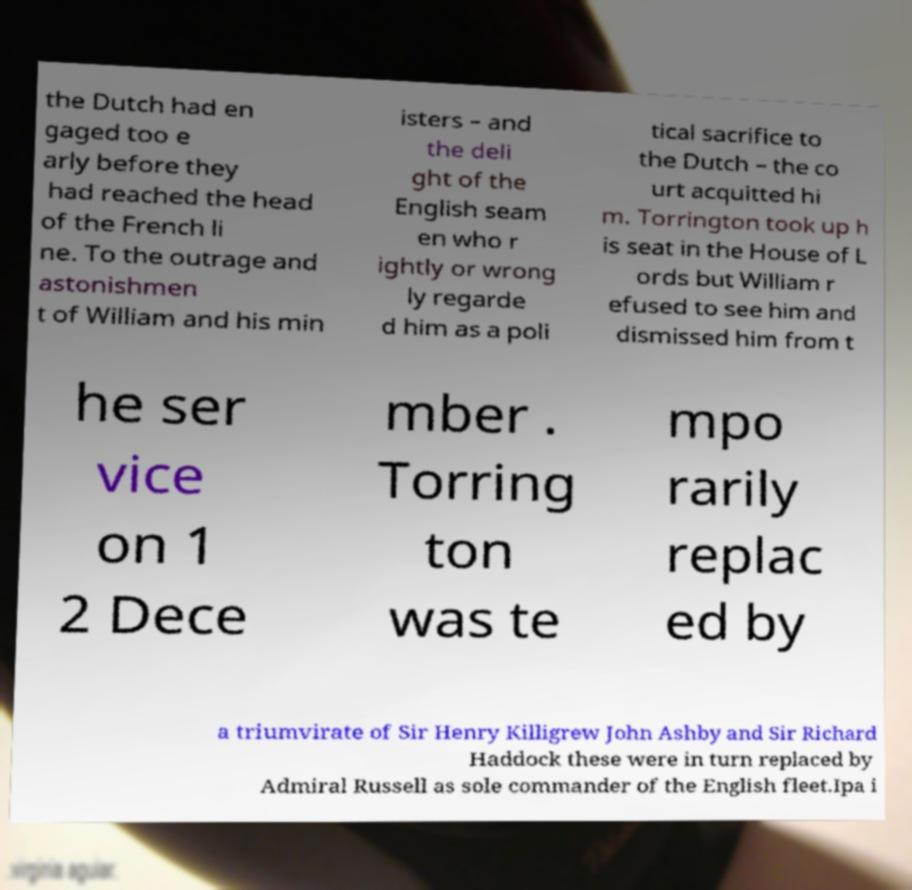There's text embedded in this image that I need extracted. Can you transcribe it verbatim? the Dutch had en gaged too e arly before they had reached the head of the French li ne. To the outrage and astonishmen t of William and his min isters – and the deli ght of the English seam en who r ightly or wrong ly regarde d him as a poli tical sacrifice to the Dutch – the co urt acquitted hi m. Torrington took up h is seat in the House of L ords but William r efused to see him and dismissed him from t he ser vice on 1 2 Dece mber . Torring ton was te mpo rarily replac ed by a triumvirate of Sir Henry Killigrew John Ashby and Sir Richard Haddock these were in turn replaced by Admiral Russell as sole commander of the English fleet.Ipa i 